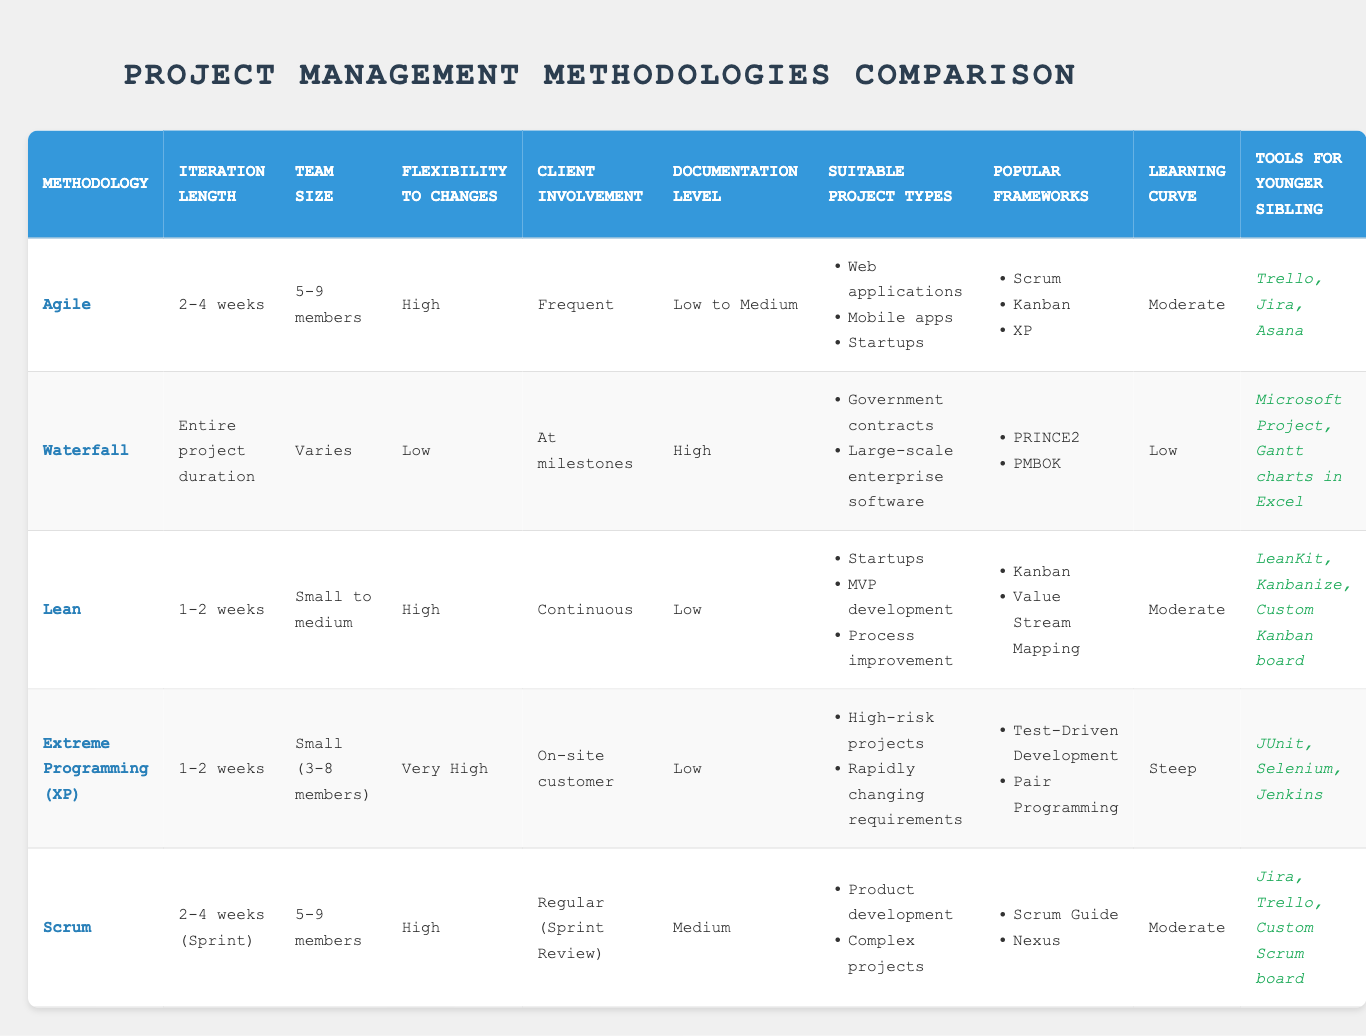What is the iteration length for Agile methodology? The iteration length for Agile methodology is stated in the table as "2-4 weeks."
Answer: 2-4 weeks How many members typically form a team in Extreme Programming (XP)? The table specifies that the team size in Extreme Programming (XP) is "Small (3-8 members)."
Answer: Small (3-8 members) Is the flexibility to changes for Waterfall methodology high? The table indicates that the flexibility to changes for Waterfall is "Low," which confirms that it is not high.
Answer: No Which methodologies have a high flexibility to changes? By scanning the flexibility column for methodologies marked "High," we find that Agile, Lean, and Scrum fall into this category.
Answer: Agile, Lean, Scrum What is the average learning curve level for the methodologies listed? The methodologies can be categorized as Low (Waterfall), Moderate (Agile, Lean, Scrum), and Steep (Extreme Programming). When counting, we have 1 low, 3 moderate, and 1 steep. The average would place more weight on moderate, so it's reasonable to state that the average learning curve is Moderate.
Answer: Moderate What is the main documentation level for Scrum? Referring to the table, Scrum's documentation level is listed as "Medium."
Answer: Medium Are there any methodologies that allow for continuous client involvement? The table shows that both Lean and Extreme Programming (XP) indicate "Continuous" and "On-site customer" respectively, suggesting continuous engagement. Therefore, at least two methodologies fit this criterion.
Answer: Yes What types of projects are suitable for Waterfall methodology? According to the table, suitable project types for Waterfall are listed as "Government contracts" and "Large-scale enterprise software."
Answer: Government contracts, Large-scale enterprise software Which methodology has the steepest learning curve? The table indicates that Extreme Programming (XP) has a "Steep" learning curve, the highest compared to the others.
Answer: Extreme Programming (XP) 